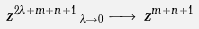Convert formula to latex. <formula><loc_0><loc_0><loc_500><loc_500>z ^ { 2 \lambda + m + n + 1 } \, _ { \lambda \rightarrow 0 } \longrightarrow \, z ^ { m + n + 1 }</formula> 